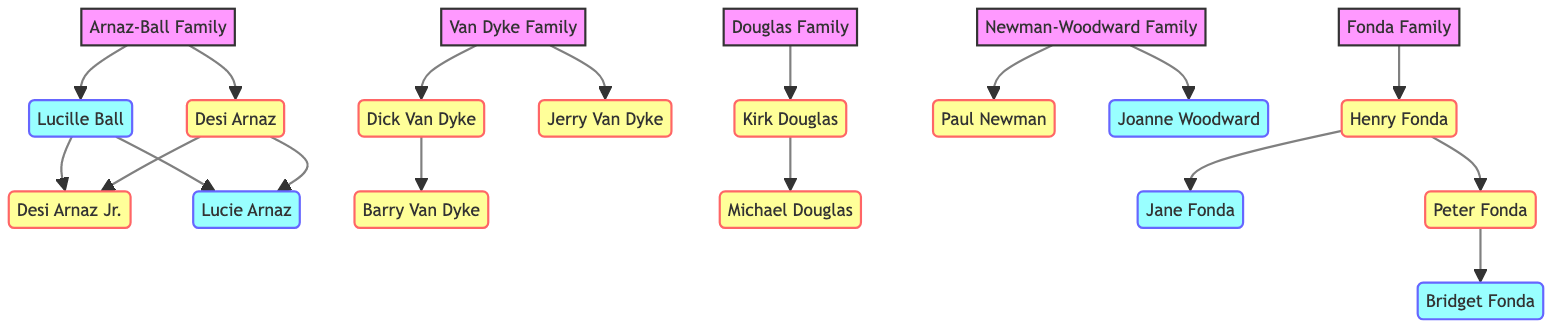What is the first name of the actress in the Arnaz-Ball family? The diagram indicates that Lucille Ball is an actress and a member of the Arnaz-Ball Family.
Answer: Lucille How many actors are in the Van Dyke family? The Van Dyke family includes Dick Van Dyke, Barry Van Dyke, and Jerry Van Dyke, making a total of three actors.
Answer: 3 Which famous show is associated with Jane Fonda? On the diagram, Jane Fonda is linked to the show "Grace and Frankie," indicating her association with it.
Answer: Grace and Frankie Who is the parent of Bridget Fonda? The diagram shows that Peter Fonda is connected to Bridget Fonda, implying he is her father.
Answer: Peter Fonda Which family includes both an actor and an actress named after Newman? The Newman-Woodward Family is the one that includes Paul Newman and Joanne Woodward, an actor and an actress respectively.
Answer: Newman-Woodward Family What role does Desi Arnaz play in the Arnaz-Ball family? In the family tree, Desi Arnaz is labeled as an actor, identifying his role within the Arnaz-Ball family.
Answer: Actor Which family does Michael Douglas belong to? According to the diagram, Michael Douglas is a member of the Douglas Family.
Answer: Douglas Family How many total members are in the Fonda family? The Fonda family consists of four members: Henry Fonda, Jane Fonda, Peter Fonda, and Bridget Fonda, totaling four individuals.
Answer: 4 Which actor shares a famous show with Dick Van Dyke? Barry Van Dyke shares the show "Diagnosis: Murder" with Dick Van Dyke, indicating a connection through their work.
Answer: Barry Van Dyke 